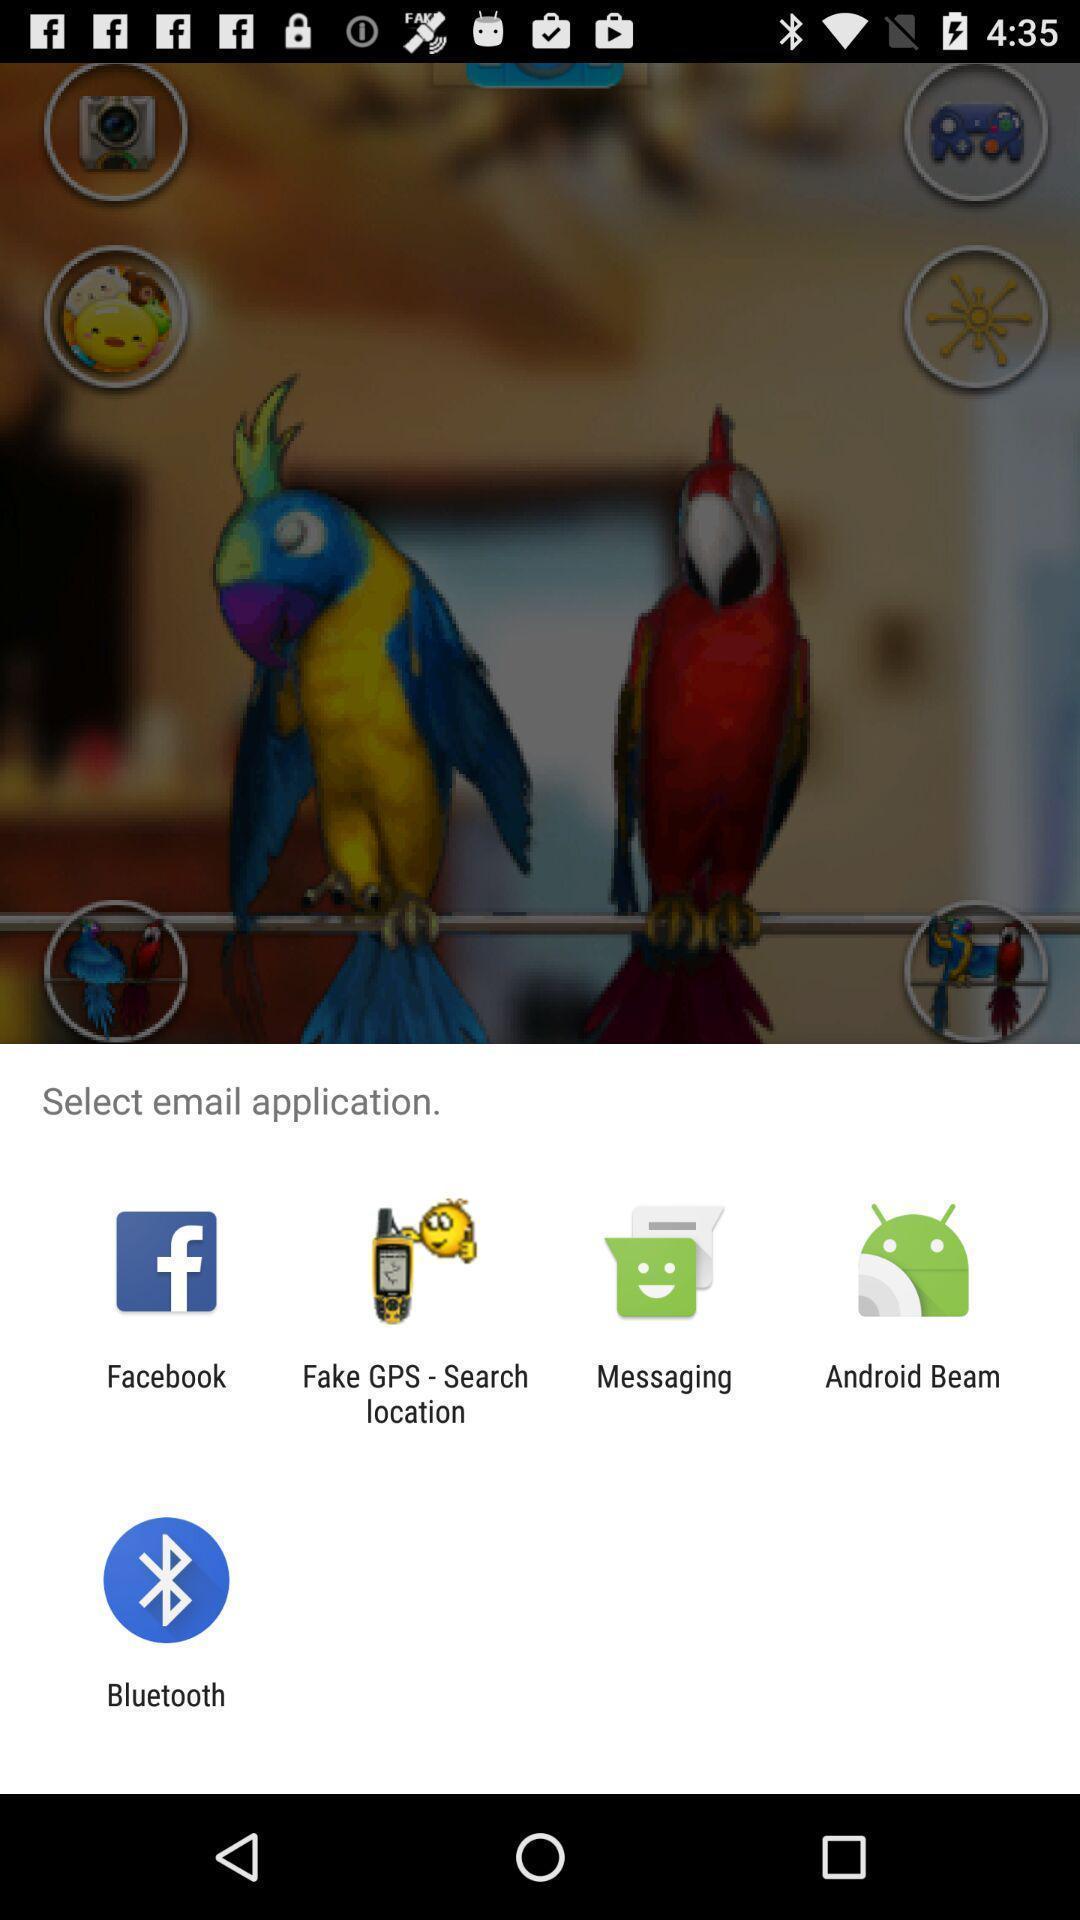Describe this image in words. Pop-up for selection of various email application. 